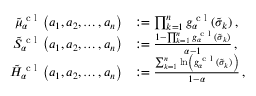<formula> <loc_0><loc_0><loc_500><loc_500>\begin{array} { r l } { \tilde { \mu } _ { \alpha } ^ { c l } \left ( a _ { 1 } , a _ { 2 } , \dots , a _ { n } \right ) } & { \colon = \prod _ { k = 1 } ^ { n } g _ { \alpha } ^ { c l } ( \tilde { \sigma } _ { k } ) \, , } \\ { \tilde { S } _ { \alpha } ^ { c l } \left ( a _ { 1 } , a _ { 2 } , \dots , a _ { n } \right ) } & { \colon = \frac { 1 - \prod _ { k = 1 } ^ { n } g _ { \alpha } ^ { c l } ( \tilde { \sigma } _ { k } ) } { \alpha - 1 } \, , } \\ { \tilde { H } _ { \alpha } ^ { c l } \left ( a _ { 1 } , a _ { 2 } , \dots , a _ { n } \right ) } & { \colon = \frac { \sum _ { k = 1 } ^ { n } \ln \left ( g _ { \alpha } ^ { c l } ( \tilde { \sigma } _ { k } ) \right ) } { 1 - \alpha } \, , } \end{array}</formula> 